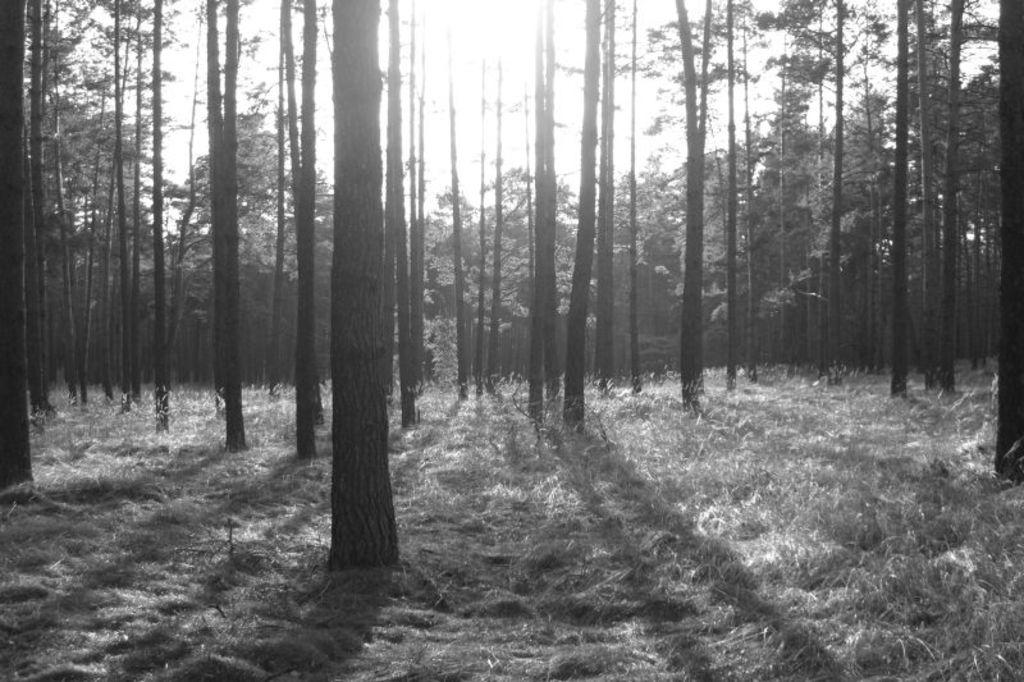What is located in the center of the image? There are trees in the center of the image. What is visible at the top of the image? The sky is visible at the top of the image. What type of vegetation is present at the bottom of the image? Grass is present at the bottom of the image. What else can be seen at the bottom of the image? The ground is visible at the bottom of the image. What type of books can be seen on the amusement ride in the image? There are no books or amusement rides present in the image; it features trees, sky, grass, and ground. What time of day is it in the image, considering the presence of the afternoon sun? The image does not provide information about the time of day, as there is no mention of the sun or any specific lighting conditions. 